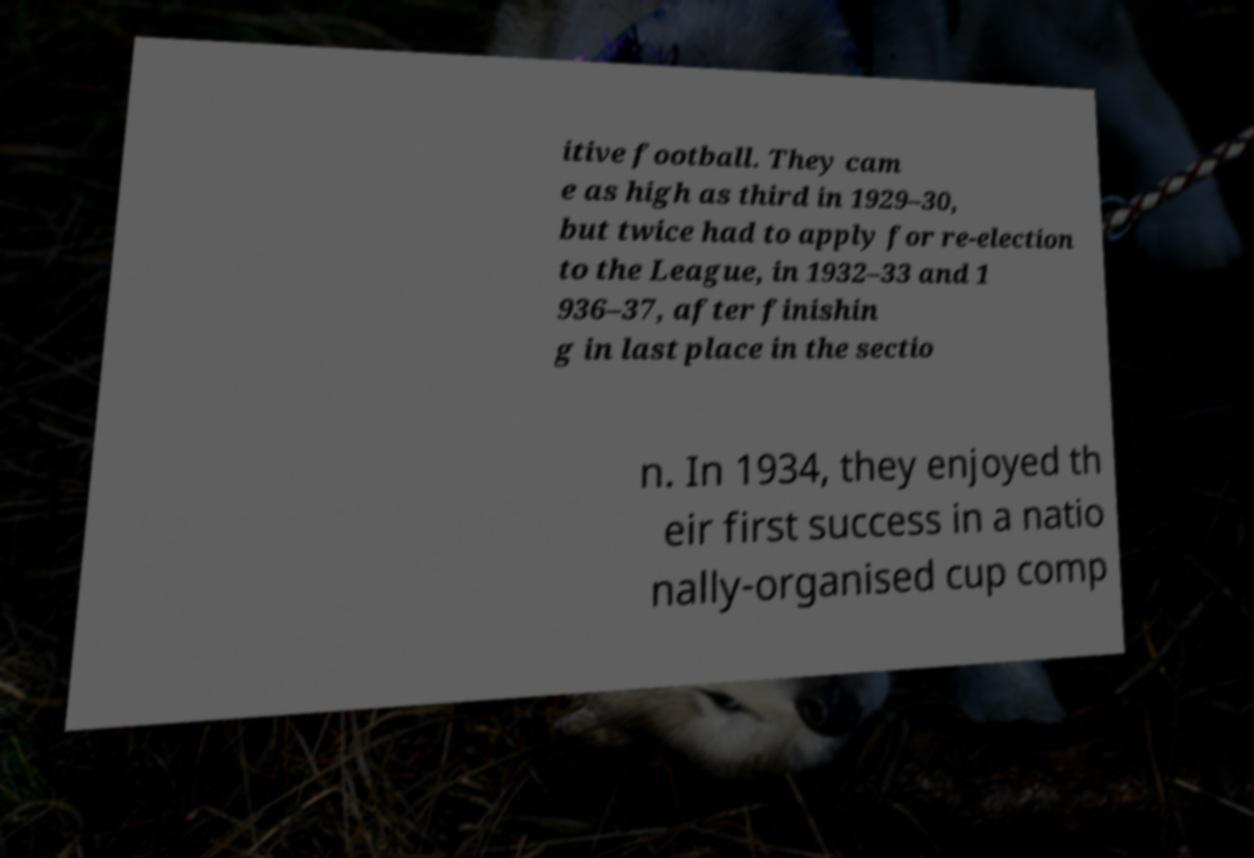Please identify and transcribe the text found in this image. itive football. They cam e as high as third in 1929–30, but twice had to apply for re-election to the League, in 1932–33 and 1 936–37, after finishin g in last place in the sectio n. In 1934, they enjoyed th eir first success in a natio nally-organised cup comp 